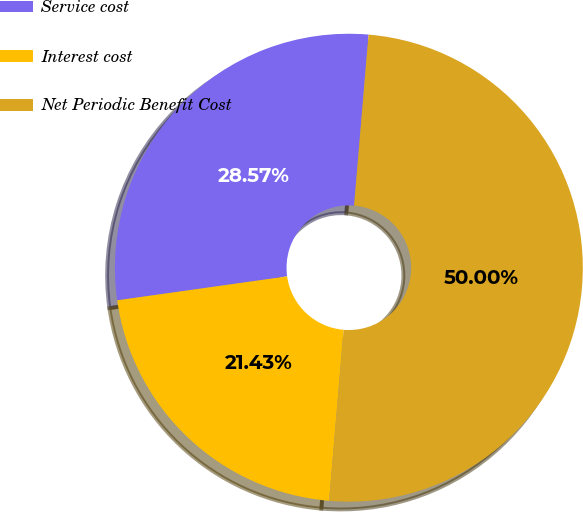<chart> <loc_0><loc_0><loc_500><loc_500><pie_chart><fcel>Service cost<fcel>Interest cost<fcel>Net Periodic Benefit Cost<nl><fcel>28.57%<fcel>21.43%<fcel>50.0%<nl></chart> 